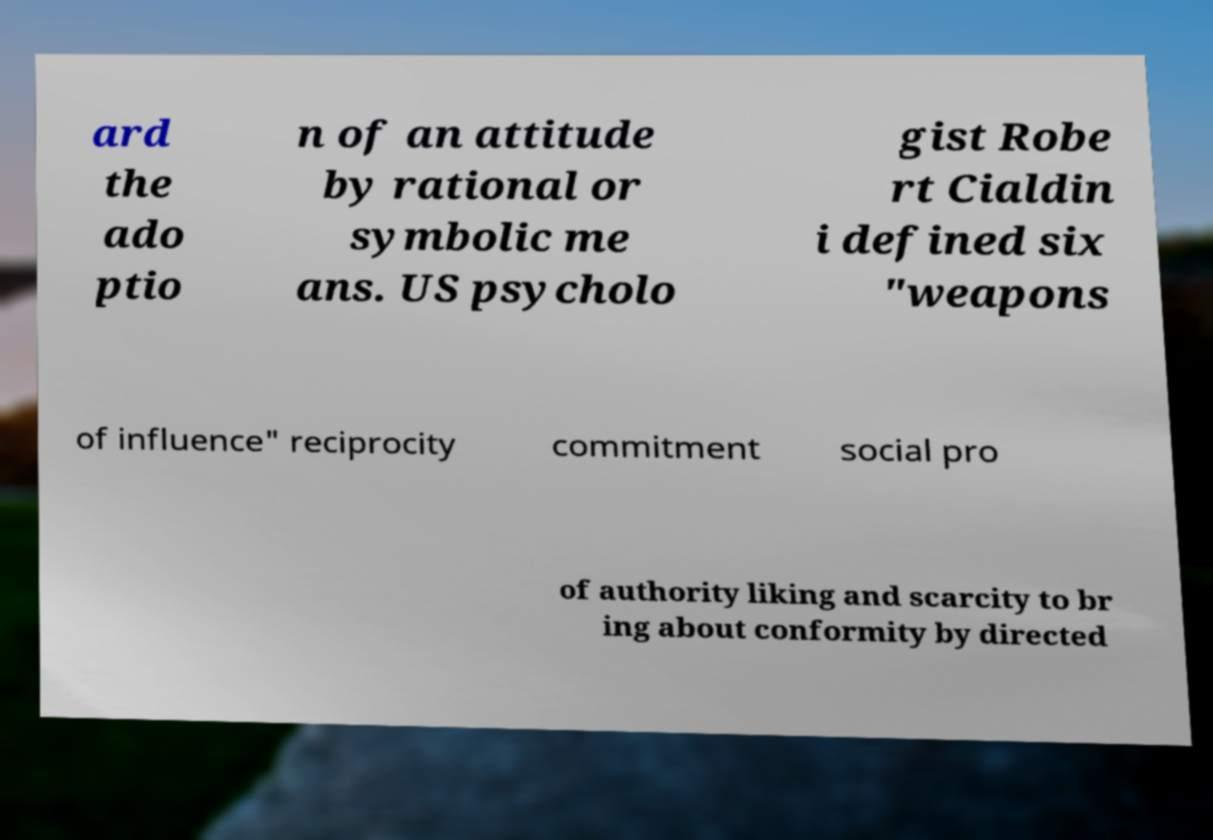Please read and relay the text visible in this image. What does it say? ard the ado ptio n of an attitude by rational or symbolic me ans. US psycholo gist Robe rt Cialdin i defined six "weapons of influence" reciprocity commitment social pro of authority liking and scarcity to br ing about conformity by directed 